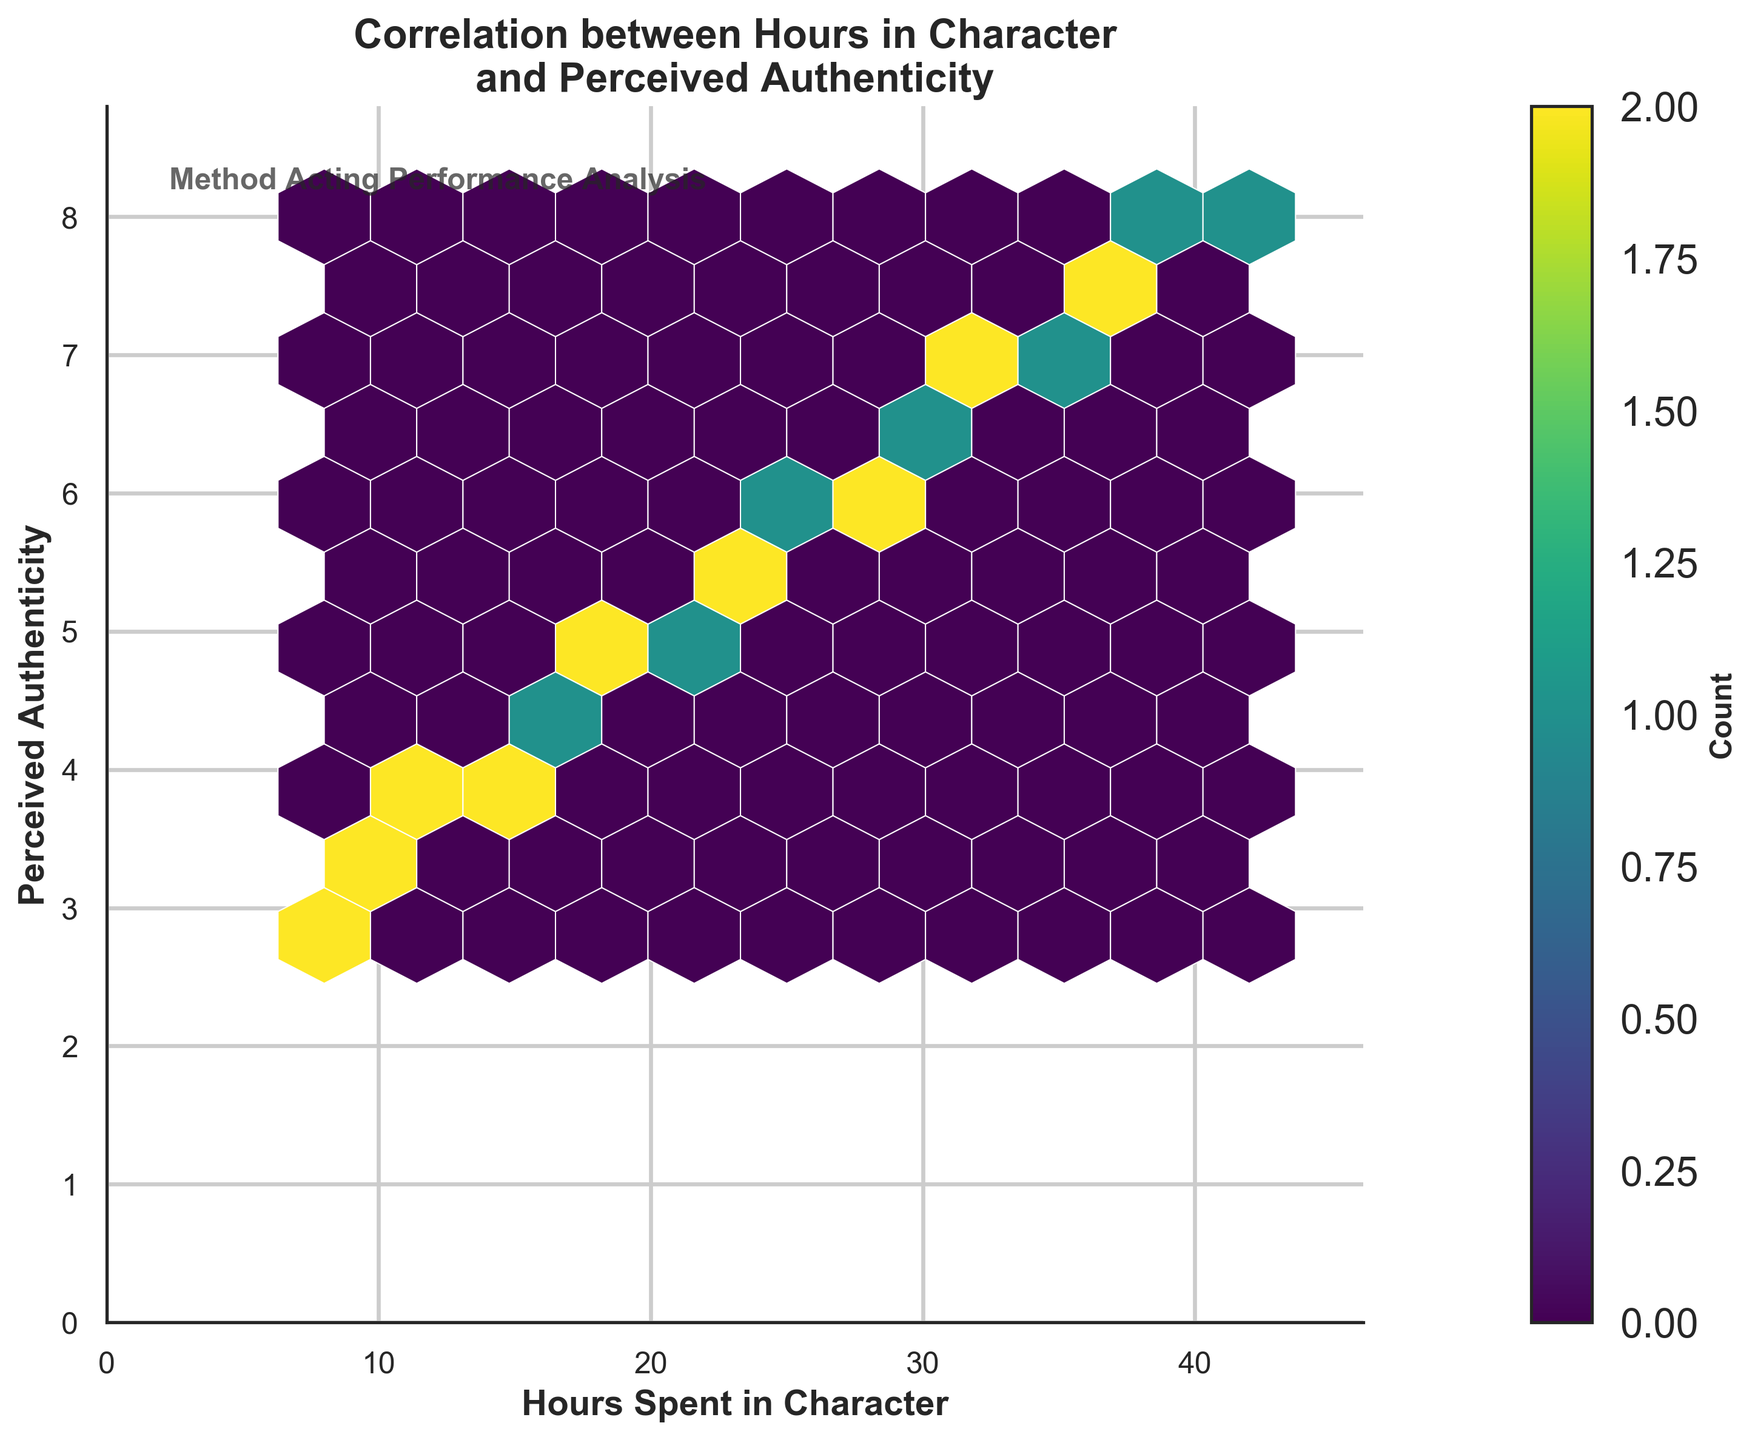What is the title of the plot? The title is displayed at the top of the plot, indicating what the plot represents.
Answer: Correlation between Hours in Character and Perceived Authenticity What do the colors in the hexbin plot represent? The color in a hexbin plot typically represents the density of data points within the hexagon, with darker shades showing more data points.
Answer: Density of data points What are the axes' labels in the plot? The labels on the axes specify what each axis represents. In this plot, the x-axis represents "Hours Spent in Character," and the y-axis represents "Perceived Authenticity."
Answer: Hours Spent in Character and Perceived Authenticity How are higher densities shown in this hexbin plot? Hexagons with higher densities of data points are represented by darker colors in the plot.
Answer: Darker colors What's the approximate range of "Hours Spent in Character"? To find the range, observe the limits set on the x-axis. Here, it ranges from 0 to slightly above the maximum data point value (about 42 hours).
Answer: 0 to about 42 hours What's the general trend observed between "Hours Spent in Character" and "Perceived Authenticity"? By observing the scatter and the color density in the plot, a positive correlation can be seen, indicating that as the hours spent in character increase, perceived authenticity also increases.
Answer: Positive correlation Which range of hours spent in character contains the highest density of data points? The highest density areas, shown by the darkest hexagons, are most concentrated around certain hours. By looking at the plot, the densest regions seem to occur roughly between 20 to 30 hours spent in character.
Answer: 20 to 30 hours What is the perceived authenticity when the hours spent in character are around 35? Find where the x-axis value is approximately 35 and see the corresponding y-axis values. It appears around 7.2.
Answer: 7.2 If an actor spends 10 hours in character, what is the approximate range of their perceived authenticity? Locate the value 10 on the x-axis and trace vertically to identify the range of values on the y-axis. It appears to range around 3.2.
Answer: Around 3.2 What does the size of the hexagons in the hexbin plot indicate? In a hexbin plot, the size of the hexagons typically does not change, but their color intensity visualizes the count of data points within each hexagon.
Answer: Fixed size, color indicates count 